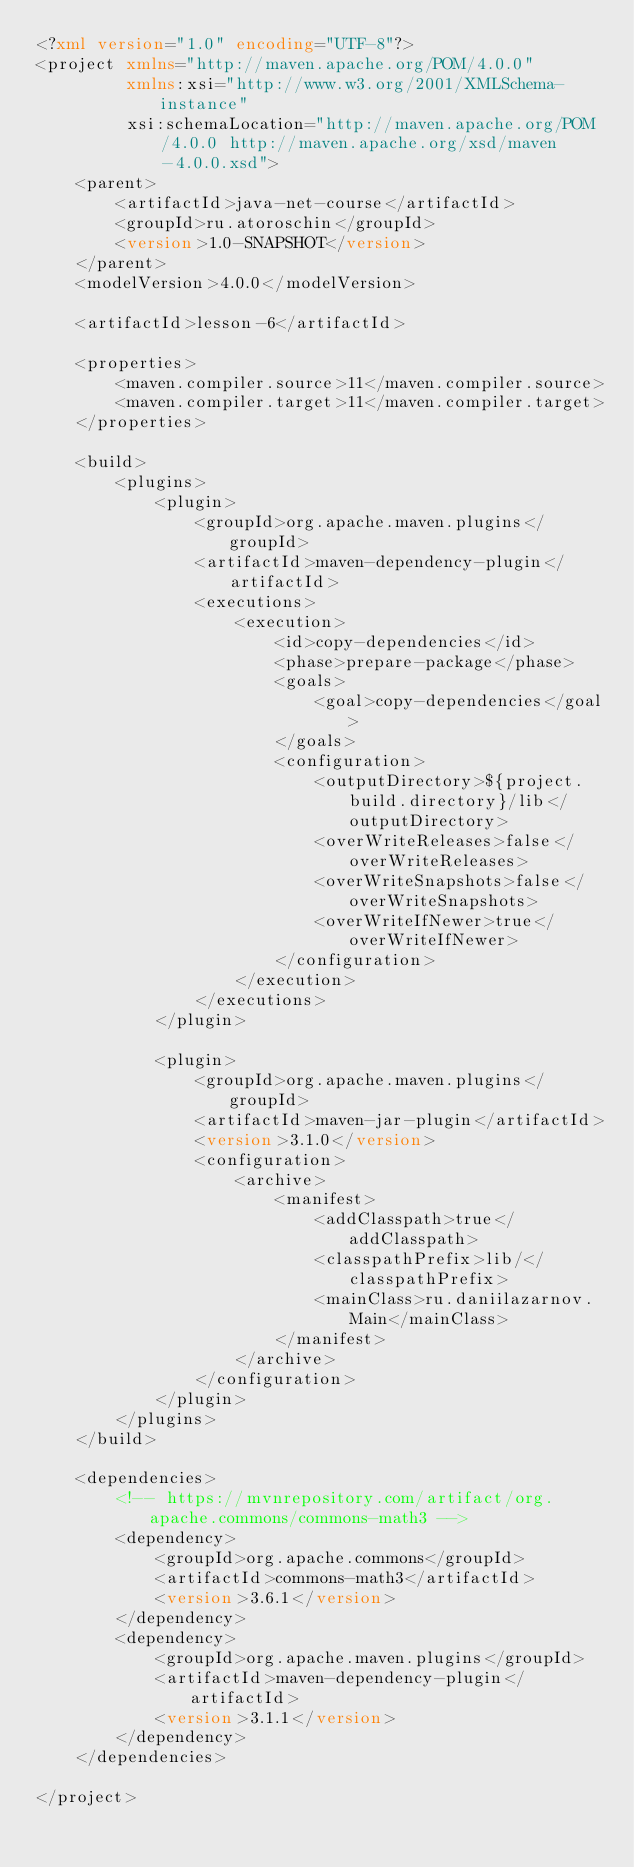<code> <loc_0><loc_0><loc_500><loc_500><_XML_><?xml version="1.0" encoding="UTF-8"?>
<project xmlns="http://maven.apache.org/POM/4.0.0"
         xmlns:xsi="http://www.w3.org/2001/XMLSchema-instance"
         xsi:schemaLocation="http://maven.apache.org/POM/4.0.0 http://maven.apache.org/xsd/maven-4.0.0.xsd">
    <parent>
        <artifactId>java-net-course</artifactId>
        <groupId>ru.atoroschin</groupId>
        <version>1.0-SNAPSHOT</version>
    </parent>
    <modelVersion>4.0.0</modelVersion>

    <artifactId>lesson-6</artifactId>

    <properties>
        <maven.compiler.source>11</maven.compiler.source>
        <maven.compiler.target>11</maven.compiler.target>
    </properties>

    <build>
        <plugins>
            <plugin>
                <groupId>org.apache.maven.plugins</groupId>
                <artifactId>maven-dependency-plugin</artifactId>
                <executions>
                    <execution>
                        <id>copy-dependencies</id>
                        <phase>prepare-package</phase>
                        <goals>
                            <goal>copy-dependencies</goal>
                        </goals>
                        <configuration>
                            <outputDirectory>${project.build.directory}/lib</outputDirectory>
                            <overWriteReleases>false</overWriteReleases>
                            <overWriteSnapshots>false</overWriteSnapshots>
                            <overWriteIfNewer>true</overWriteIfNewer>
                        </configuration>
                    </execution>
                </executions>
            </plugin>

            <plugin>
                <groupId>org.apache.maven.plugins</groupId>
                <artifactId>maven-jar-plugin</artifactId>
                <version>3.1.0</version>
                <configuration>
                    <archive>
                        <manifest>
                            <addClasspath>true</addClasspath>
                            <classpathPrefix>lib/</classpathPrefix>
                            <mainClass>ru.daniilazarnov.Main</mainClass>
                        </manifest>
                    </archive>
                </configuration>
            </plugin>
        </plugins>
    </build>

    <dependencies>
        <!-- https://mvnrepository.com/artifact/org.apache.commons/commons-math3 -->
        <dependency>
            <groupId>org.apache.commons</groupId>
            <artifactId>commons-math3</artifactId>
            <version>3.6.1</version>
        </dependency>
        <dependency>
            <groupId>org.apache.maven.plugins</groupId>
            <artifactId>maven-dependency-plugin</artifactId>
            <version>3.1.1</version>
        </dependency>
    </dependencies>

</project>
</code> 